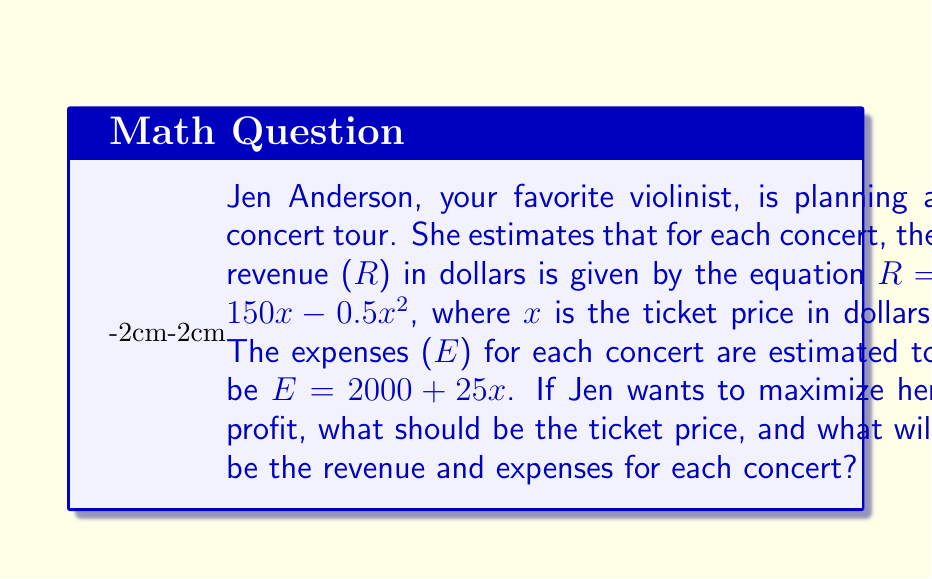Teach me how to tackle this problem. To solve this problem, we'll follow these steps:

1) First, we need to find the profit function. Profit (P) is the difference between revenue (R) and expenses (E):

   $P = R - E = (150x - 0.5x^2) - (2000 + 25x)$
   $P = 150x - 0.5x^2 - 2000 - 25x$
   $P = -0.5x^2 + 125x - 2000$

2) To maximize profit, we need to find the vertex of this quadratic function. We can do this by finding where the derivative of P equals zero:

   $\frac{dP}{dx} = -x + 125$
   
   Set this equal to zero:
   $-x + 125 = 0$
   $x = 125$

3) This means the optimal ticket price is $125.

4) Now we can calculate the revenue at this price:
   
   $R = 150x - 0.5x^2$
   $R = 150(125) - 0.5(125)^2$
   $R = 18750 - 7812.5$
   $R = 10937.50$

5) And the expenses:

   $E = 2000 + 25x$
   $E = 2000 + 25(125)$
   $E = 2000 + 3125$
   $E = 5125$

Therefore, at the optimal ticket price of $125, the revenue for each concert will be $10,937.50, and the expenses will be $5,125.
Answer: Optimal ticket price: $125
Revenue per concert: $10,937.50
Expenses per concert: $5,125 